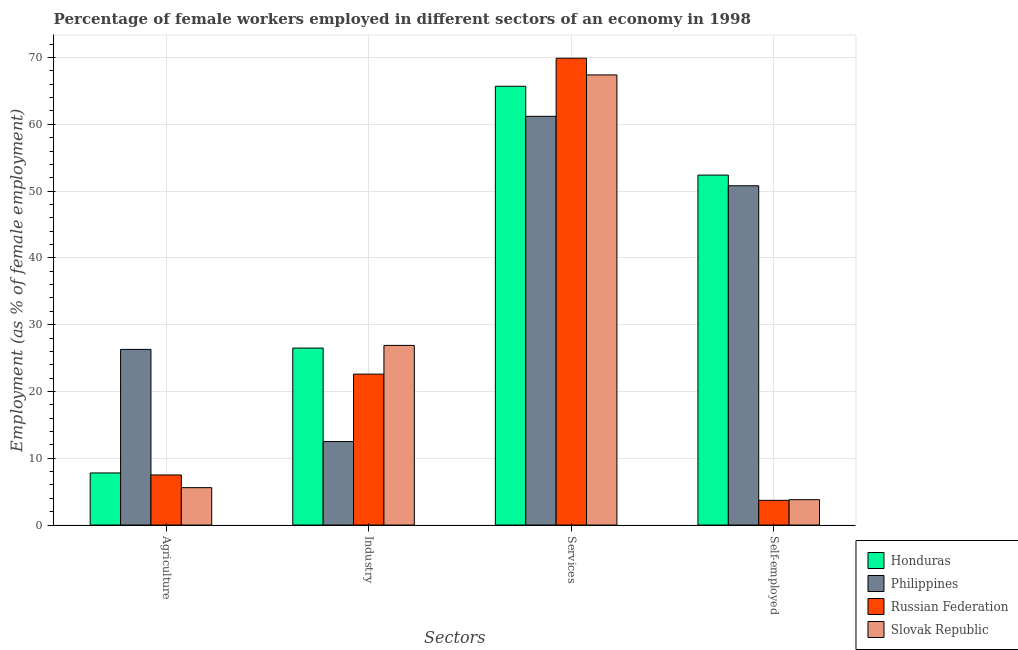Are the number of bars on each tick of the X-axis equal?
Make the answer very short. Yes. How many bars are there on the 3rd tick from the right?
Provide a succinct answer. 4. What is the label of the 3rd group of bars from the left?
Provide a succinct answer. Services. What is the percentage of female workers in industry in Honduras?
Provide a short and direct response. 26.5. Across all countries, what is the maximum percentage of female workers in services?
Provide a succinct answer. 69.9. Across all countries, what is the minimum percentage of female workers in agriculture?
Provide a short and direct response. 5.6. In which country was the percentage of female workers in industry maximum?
Your answer should be compact. Slovak Republic. In which country was the percentage of female workers in industry minimum?
Your response must be concise. Philippines. What is the total percentage of self employed female workers in the graph?
Offer a terse response. 110.7. What is the difference between the percentage of female workers in agriculture in Philippines and that in Honduras?
Offer a very short reply. 18.5. What is the difference between the percentage of female workers in agriculture in Slovak Republic and the percentage of self employed female workers in Philippines?
Offer a very short reply. -45.2. What is the average percentage of self employed female workers per country?
Make the answer very short. 27.68. What is the difference between the percentage of female workers in services and percentage of female workers in agriculture in Honduras?
Provide a short and direct response. 57.9. In how many countries, is the percentage of female workers in services greater than 38 %?
Your answer should be very brief. 4. What is the ratio of the percentage of self employed female workers in Slovak Republic to that in Russian Federation?
Ensure brevity in your answer.  1.03. What is the difference between the highest and the second highest percentage of female workers in services?
Keep it short and to the point. 2.5. What is the difference between the highest and the lowest percentage of female workers in agriculture?
Offer a terse response. 20.7. Is it the case that in every country, the sum of the percentage of female workers in services and percentage of female workers in industry is greater than the sum of percentage of self employed female workers and percentage of female workers in agriculture?
Keep it short and to the point. Yes. What does the 3rd bar from the left in Agriculture represents?
Your answer should be very brief. Russian Federation. What does the 1st bar from the right in Industry represents?
Your answer should be very brief. Slovak Republic. Is it the case that in every country, the sum of the percentage of female workers in agriculture and percentage of female workers in industry is greater than the percentage of female workers in services?
Offer a terse response. No. How many bars are there?
Ensure brevity in your answer.  16. Are all the bars in the graph horizontal?
Keep it short and to the point. No. What is the difference between two consecutive major ticks on the Y-axis?
Your answer should be compact. 10. Does the graph contain grids?
Offer a terse response. Yes. Where does the legend appear in the graph?
Provide a short and direct response. Bottom right. What is the title of the graph?
Offer a terse response. Percentage of female workers employed in different sectors of an economy in 1998. What is the label or title of the X-axis?
Your response must be concise. Sectors. What is the label or title of the Y-axis?
Provide a succinct answer. Employment (as % of female employment). What is the Employment (as % of female employment) in Honduras in Agriculture?
Ensure brevity in your answer.  7.8. What is the Employment (as % of female employment) of Philippines in Agriculture?
Offer a very short reply. 26.3. What is the Employment (as % of female employment) in Russian Federation in Agriculture?
Give a very brief answer. 7.5. What is the Employment (as % of female employment) of Slovak Republic in Agriculture?
Offer a very short reply. 5.6. What is the Employment (as % of female employment) of Russian Federation in Industry?
Make the answer very short. 22.6. What is the Employment (as % of female employment) in Slovak Republic in Industry?
Give a very brief answer. 26.9. What is the Employment (as % of female employment) in Honduras in Services?
Your response must be concise. 65.7. What is the Employment (as % of female employment) of Philippines in Services?
Make the answer very short. 61.2. What is the Employment (as % of female employment) in Russian Federation in Services?
Keep it short and to the point. 69.9. What is the Employment (as % of female employment) in Slovak Republic in Services?
Provide a short and direct response. 67.4. What is the Employment (as % of female employment) in Honduras in Self-employed?
Your answer should be compact. 52.4. What is the Employment (as % of female employment) in Philippines in Self-employed?
Ensure brevity in your answer.  50.8. What is the Employment (as % of female employment) in Russian Federation in Self-employed?
Your answer should be very brief. 3.7. What is the Employment (as % of female employment) of Slovak Republic in Self-employed?
Provide a short and direct response. 3.8. Across all Sectors, what is the maximum Employment (as % of female employment) of Honduras?
Give a very brief answer. 65.7. Across all Sectors, what is the maximum Employment (as % of female employment) of Philippines?
Provide a succinct answer. 61.2. Across all Sectors, what is the maximum Employment (as % of female employment) of Russian Federation?
Your answer should be very brief. 69.9. Across all Sectors, what is the maximum Employment (as % of female employment) in Slovak Republic?
Your answer should be compact. 67.4. Across all Sectors, what is the minimum Employment (as % of female employment) in Honduras?
Your answer should be compact. 7.8. Across all Sectors, what is the minimum Employment (as % of female employment) of Philippines?
Make the answer very short. 12.5. Across all Sectors, what is the minimum Employment (as % of female employment) of Russian Federation?
Provide a succinct answer. 3.7. Across all Sectors, what is the minimum Employment (as % of female employment) in Slovak Republic?
Provide a succinct answer. 3.8. What is the total Employment (as % of female employment) of Honduras in the graph?
Your answer should be compact. 152.4. What is the total Employment (as % of female employment) of Philippines in the graph?
Your answer should be compact. 150.8. What is the total Employment (as % of female employment) in Russian Federation in the graph?
Offer a very short reply. 103.7. What is the total Employment (as % of female employment) of Slovak Republic in the graph?
Provide a succinct answer. 103.7. What is the difference between the Employment (as % of female employment) of Honduras in Agriculture and that in Industry?
Make the answer very short. -18.7. What is the difference between the Employment (as % of female employment) in Philippines in Agriculture and that in Industry?
Provide a short and direct response. 13.8. What is the difference between the Employment (as % of female employment) of Russian Federation in Agriculture and that in Industry?
Provide a short and direct response. -15.1. What is the difference between the Employment (as % of female employment) of Slovak Republic in Agriculture and that in Industry?
Offer a terse response. -21.3. What is the difference between the Employment (as % of female employment) of Honduras in Agriculture and that in Services?
Your answer should be compact. -57.9. What is the difference between the Employment (as % of female employment) of Philippines in Agriculture and that in Services?
Your response must be concise. -34.9. What is the difference between the Employment (as % of female employment) of Russian Federation in Agriculture and that in Services?
Ensure brevity in your answer.  -62.4. What is the difference between the Employment (as % of female employment) of Slovak Republic in Agriculture and that in Services?
Keep it short and to the point. -61.8. What is the difference between the Employment (as % of female employment) in Honduras in Agriculture and that in Self-employed?
Ensure brevity in your answer.  -44.6. What is the difference between the Employment (as % of female employment) in Philippines in Agriculture and that in Self-employed?
Offer a very short reply. -24.5. What is the difference between the Employment (as % of female employment) of Honduras in Industry and that in Services?
Your answer should be very brief. -39.2. What is the difference between the Employment (as % of female employment) of Philippines in Industry and that in Services?
Provide a succinct answer. -48.7. What is the difference between the Employment (as % of female employment) of Russian Federation in Industry and that in Services?
Give a very brief answer. -47.3. What is the difference between the Employment (as % of female employment) in Slovak Republic in Industry and that in Services?
Provide a succinct answer. -40.5. What is the difference between the Employment (as % of female employment) in Honduras in Industry and that in Self-employed?
Provide a succinct answer. -25.9. What is the difference between the Employment (as % of female employment) of Philippines in Industry and that in Self-employed?
Provide a succinct answer. -38.3. What is the difference between the Employment (as % of female employment) of Russian Federation in Industry and that in Self-employed?
Provide a succinct answer. 18.9. What is the difference between the Employment (as % of female employment) of Slovak Republic in Industry and that in Self-employed?
Offer a terse response. 23.1. What is the difference between the Employment (as % of female employment) in Honduras in Services and that in Self-employed?
Your answer should be compact. 13.3. What is the difference between the Employment (as % of female employment) in Philippines in Services and that in Self-employed?
Ensure brevity in your answer.  10.4. What is the difference between the Employment (as % of female employment) of Russian Federation in Services and that in Self-employed?
Ensure brevity in your answer.  66.2. What is the difference between the Employment (as % of female employment) of Slovak Republic in Services and that in Self-employed?
Provide a short and direct response. 63.6. What is the difference between the Employment (as % of female employment) of Honduras in Agriculture and the Employment (as % of female employment) of Philippines in Industry?
Your answer should be compact. -4.7. What is the difference between the Employment (as % of female employment) of Honduras in Agriculture and the Employment (as % of female employment) of Russian Federation in Industry?
Provide a succinct answer. -14.8. What is the difference between the Employment (as % of female employment) in Honduras in Agriculture and the Employment (as % of female employment) in Slovak Republic in Industry?
Offer a terse response. -19.1. What is the difference between the Employment (as % of female employment) of Philippines in Agriculture and the Employment (as % of female employment) of Slovak Republic in Industry?
Offer a terse response. -0.6. What is the difference between the Employment (as % of female employment) of Russian Federation in Agriculture and the Employment (as % of female employment) of Slovak Republic in Industry?
Your answer should be very brief. -19.4. What is the difference between the Employment (as % of female employment) in Honduras in Agriculture and the Employment (as % of female employment) in Philippines in Services?
Provide a short and direct response. -53.4. What is the difference between the Employment (as % of female employment) of Honduras in Agriculture and the Employment (as % of female employment) of Russian Federation in Services?
Your answer should be compact. -62.1. What is the difference between the Employment (as % of female employment) of Honduras in Agriculture and the Employment (as % of female employment) of Slovak Republic in Services?
Ensure brevity in your answer.  -59.6. What is the difference between the Employment (as % of female employment) of Philippines in Agriculture and the Employment (as % of female employment) of Russian Federation in Services?
Provide a short and direct response. -43.6. What is the difference between the Employment (as % of female employment) in Philippines in Agriculture and the Employment (as % of female employment) in Slovak Republic in Services?
Keep it short and to the point. -41.1. What is the difference between the Employment (as % of female employment) of Russian Federation in Agriculture and the Employment (as % of female employment) of Slovak Republic in Services?
Your answer should be compact. -59.9. What is the difference between the Employment (as % of female employment) in Honduras in Agriculture and the Employment (as % of female employment) in Philippines in Self-employed?
Your answer should be very brief. -43. What is the difference between the Employment (as % of female employment) of Honduras in Agriculture and the Employment (as % of female employment) of Slovak Republic in Self-employed?
Your answer should be very brief. 4. What is the difference between the Employment (as % of female employment) of Philippines in Agriculture and the Employment (as % of female employment) of Russian Federation in Self-employed?
Provide a short and direct response. 22.6. What is the difference between the Employment (as % of female employment) in Philippines in Agriculture and the Employment (as % of female employment) in Slovak Republic in Self-employed?
Ensure brevity in your answer.  22.5. What is the difference between the Employment (as % of female employment) in Honduras in Industry and the Employment (as % of female employment) in Philippines in Services?
Make the answer very short. -34.7. What is the difference between the Employment (as % of female employment) in Honduras in Industry and the Employment (as % of female employment) in Russian Federation in Services?
Your answer should be very brief. -43.4. What is the difference between the Employment (as % of female employment) in Honduras in Industry and the Employment (as % of female employment) in Slovak Republic in Services?
Provide a succinct answer. -40.9. What is the difference between the Employment (as % of female employment) of Philippines in Industry and the Employment (as % of female employment) of Russian Federation in Services?
Make the answer very short. -57.4. What is the difference between the Employment (as % of female employment) in Philippines in Industry and the Employment (as % of female employment) in Slovak Republic in Services?
Give a very brief answer. -54.9. What is the difference between the Employment (as % of female employment) in Russian Federation in Industry and the Employment (as % of female employment) in Slovak Republic in Services?
Provide a succinct answer. -44.8. What is the difference between the Employment (as % of female employment) in Honduras in Industry and the Employment (as % of female employment) in Philippines in Self-employed?
Provide a short and direct response. -24.3. What is the difference between the Employment (as % of female employment) in Honduras in Industry and the Employment (as % of female employment) in Russian Federation in Self-employed?
Provide a succinct answer. 22.8. What is the difference between the Employment (as % of female employment) in Honduras in Industry and the Employment (as % of female employment) in Slovak Republic in Self-employed?
Provide a short and direct response. 22.7. What is the difference between the Employment (as % of female employment) of Philippines in Industry and the Employment (as % of female employment) of Russian Federation in Self-employed?
Provide a short and direct response. 8.8. What is the difference between the Employment (as % of female employment) of Russian Federation in Industry and the Employment (as % of female employment) of Slovak Republic in Self-employed?
Provide a succinct answer. 18.8. What is the difference between the Employment (as % of female employment) in Honduras in Services and the Employment (as % of female employment) in Philippines in Self-employed?
Your response must be concise. 14.9. What is the difference between the Employment (as % of female employment) of Honduras in Services and the Employment (as % of female employment) of Slovak Republic in Self-employed?
Ensure brevity in your answer.  61.9. What is the difference between the Employment (as % of female employment) in Philippines in Services and the Employment (as % of female employment) in Russian Federation in Self-employed?
Offer a terse response. 57.5. What is the difference between the Employment (as % of female employment) in Philippines in Services and the Employment (as % of female employment) in Slovak Republic in Self-employed?
Ensure brevity in your answer.  57.4. What is the difference between the Employment (as % of female employment) of Russian Federation in Services and the Employment (as % of female employment) of Slovak Republic in Self-employed?
Provide a succinct answer. 66.1. What is the average Employment (as % of female employment) of Honduras per Sectors?
Provide a short and direct response. 38.1. What is the average Employment (as % of female employment) in Philippines per Sectors?
Keep it short and to the point. 37.7. What is the average Employment (as % of female employment) of Russian Federation per Sectors?
Make the answer very short. 25.93. What is the average Employment (as % of female employment) in Slovak Republic per Sectors?
Your answer should be compact. 25.93. What is the difference between the Employment (as % of female employment) in Honduras and Employment (as % of female employment) in Philippines in Agriculture?
Keep it short and to the point. -18.5. What is the difference between the Employment (as % of female employment) in Honduras and Employment (as % of female employment) in Russian Federation in Agriculture?
Your answer should be compact. 0.3. What is the difference between the Employment (as % of female employment) in Honduras and Employment (as % of female employment) in Slovak Republic in Agriculture?
Your answer should be compact. 2.2. What is the difference between the Employment (as % of female employment) of Philippines and Employment (as % of female employment) of Slovak Republic in Agriculture?
Give a very brief answer. 20.7. What is the difference between the Employment (as % of female employment) of Russian Federation and Employment (as % of female employment) of Slovak Republic in Agriculture?
Give a very brief answer. 1.9. What is the difference between the Employment (as % of female employment) of Honduras and Employment (as % of female employment) of Philippines in Industry?
Your answer should be compact. 14. What is the difference between the Employment (as % of female employment) in Philippines and Employment (as % of female employment) in Slovak Republic in Industry?
Give a very brief answer. -14.4. What is the difference between the Employment (as % of female employment) of Russian Federation and Employment (as % of female employment) of Slovak Republic in Industry?
Your answer should be compact. -4.3. What is the difference between the Employment (as % of female employment) in Honduras and Employment (as % of female employment) in Slovak Republic in Services?
Provide a short and direct response. -1.7. What is the difference between the Employment (as % of female employment) in Philippines and Employment (as % of female employment) in Slovak Republic in Services?
Provide a short and direct response. -6.2. What is the difference between the Employment (as % of female employment) of Honduras and Employment (as % of female employment) of Philippines in Self-employed?
Offer a terse response. 1.6. What is the difference between the Employment (as % of female employment) in Honduras and Employment (as % of female employment) in Russian Federation in Self-employed?
Provide a succinct answer. 48.7. What is the difference between the Employment (as % of female employment) of Honduras and Employment (as % of female employment) of Slovak Republic in Self-employed?
Offer a very short reply. 48.6. What is the difference between the Employment (as % of female employment) of Philippines and Employment (as % of female employment) of Russian Federation in Self-employed?
Your answer should be compact. 47.1. What is the ratio of the Employment (as % of female employment) in Honduras in Agriculture to that in Industry?
Ensure brevity in your answer.  0.29. What is the ratio of the Employment (as % of female employment) of Philippines in Agriculture to that in Industry?
Give a very brief answer. 2.1. What is the ratio of the Employment (as % of female employment) in Russian Federation in Agriculture to that in Industry?
Give a very brief answer. 0.33. What is the ratio of the Employment (as % of female employment) of Slovak Republic in Agriculture to that in Industry?
Provide a succinct answer. 0.21. What is the ratio of the Employment (as % of female employment) in Honduras in Agriculture to that in Services?
Offer a terse response. 0.12. What is the ratio of the Employment (as % of female employment) in Philippines in Agriculture to that in Services?
Give a very brief answer. 0.43. What is the ratio of the Employment (as % of female employment) in Russian Federation in Agriculture to that in Services?
Provide a succinct answer. 0.11. What is the ratio of the Employment (as % of female employment) of Slovak Republic in Agriculture to that in Services?
Give a very brief answer. 0.08. What is the ratio of the Employment (as % of female employment) of Honduras in Agriculture to that in Self-employed?
Your answer should be very brief. 0.15. What is the ratio of the Employment (as % of female employment) of Philippines in Agriculture to that in Self-employed?
Your answer should be very brief. 0.52. What is the ratio of the Employment (as % of female employment) of Russian Federation in Agriculture to that in Self-employed?
Your answer should be compact. 2.03. What is the ratio of the Employment (as % of female employment) of Slovak Republic in Agriculture to that in Self-employed?
Give a very brief answer. 1.47. What is the ratio of the Employment (as % of female employment) in Honduras in Industry to that in Services?
Make the answer very short. 0.4. What is the ratio of the Employment (as % of female employment) in Philippines in Industry to that in Services?
Provide a short and direct response. 0.2. What is the ratio of the Employment (as % of female employment) in Russian Federation in Industry to that in Services?
Your answer should be very brief. 0.32. What is the ratio of the Employment (as % of female employment) of Slovak Republic in Industry to that in Services?
Your response must be concise. 0.4. What is the ratio of the Employment (as % of female employment) of Honduras in Industry to that in Self-employed?
Ensure brevity in your answer.  0.51. What is the ratio of the Employment (as % of female employment) in Philippines in Industry to that in Self-employed?
Provide a short and direct response. 0.25. What is the ratio of the Employment (as % of female employment) of Russian Federation in Industry to that in Self-employed?
Ensure brevity in your answer.  6.11. What is the ratio of the Employment (as % of female employment) of Slovak Republic in Industry to that in Self-employed?
Provide a succinct answer. 7.08. What is the ratio of the Employment (as % of female employment) of Honduras in Services to that in Self-employed?
Offer a very short reply. 1.25. What is the ratio of the Employment (as % of female employment) of Philippines in Services to that in Self-employed?
Keep it short and to the point. 1.2. What is the ratio of the Employment (as % of female employment) in Russian Federation in Services to that in Self-employed?
Keep it short and to the point. 18.89. What is the ratio of the Employment (as % of female employment) of Slovak Republic in Services to that in Self-employed?
Ensure brevity in your answer.  17.74. What is the difference between the highest and the second highest Employment (as % of female employment) of Honduras?
Offer a terse response. 13.3. What is the difference between the highest and the second highest Employment (as % of female employment) of Philippines?
Your response must be concise. 10.4. What is the difference between the highest and the second highest Employment (as % of female employment) in Russian Federation?
Offer a very short reply. 47.3. What is the difference between the highest and the second highest Employment (as % of female employment) in Slovak Republic?
Keep it short and to the point. 40.5. What is the difference between the highest and the lowest Employment (as % of female employment) in Honduras?
Keep it short and to the point. 57.9. What is the difference between the highest and the lowest Employment (as % of female employment) in Philippines?
Provide a succinct answer. 48.7. What is the difference between the highest and the lowest Employment (as % of female employment) in Russian Federation?
Your answer should be very brief. 66.2. What is the difference between the highest and the lowest Employment (as % of female employment) in Slovak Republic?
Your response must be concise. 63.6. 